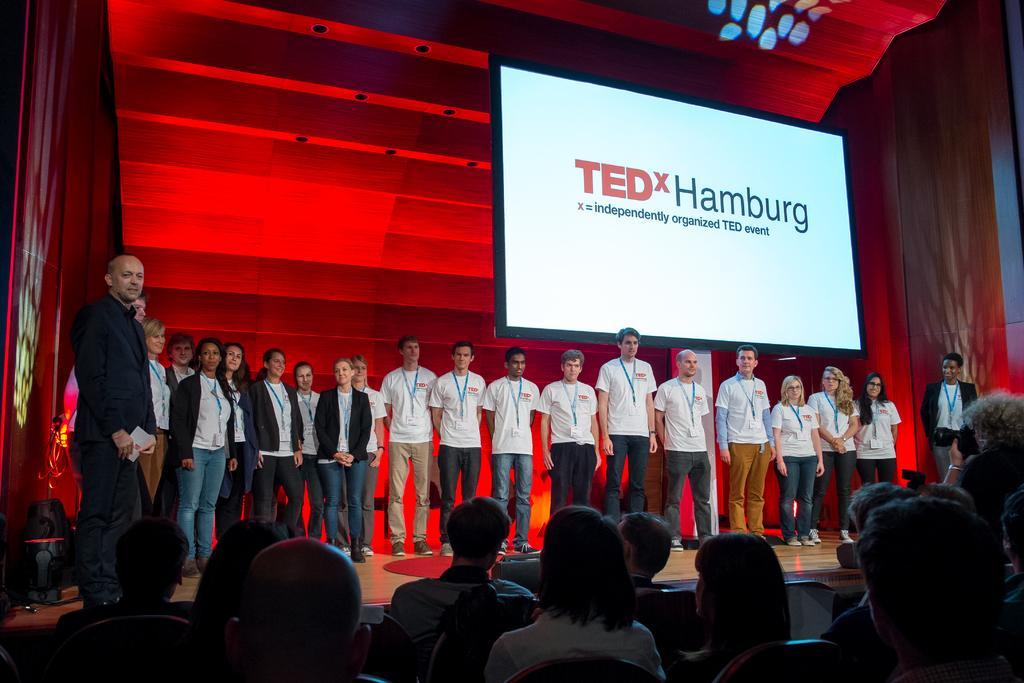Could you give a brief overview of what you see in this image? In this picture we can see a group of people are standing on the floor, some people are sitting on chairs, screen and some objects. 